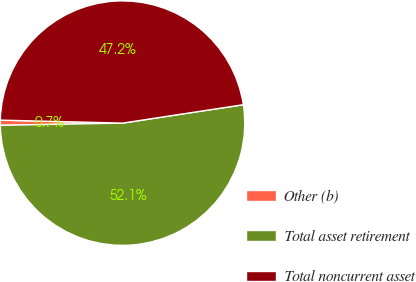<chart> <loc_0><loc_0><loc_500><loc_500><pie_chart><fcel>Other (b)<fcel>Total asset retirement<fcel>Total noncurrent asset<nl><fcel>0.68%<fcel>52.12%<fcel>47.2%<nl></chart> 